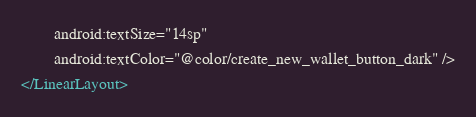Convert code to text. <code><loc_0><loc_0><loc_500><loc_500><_XML_>        android:textSize="14sp"
        android:textColor="@color/create_new_wallet_button_dark" />
</LinearLayout>

</code> 